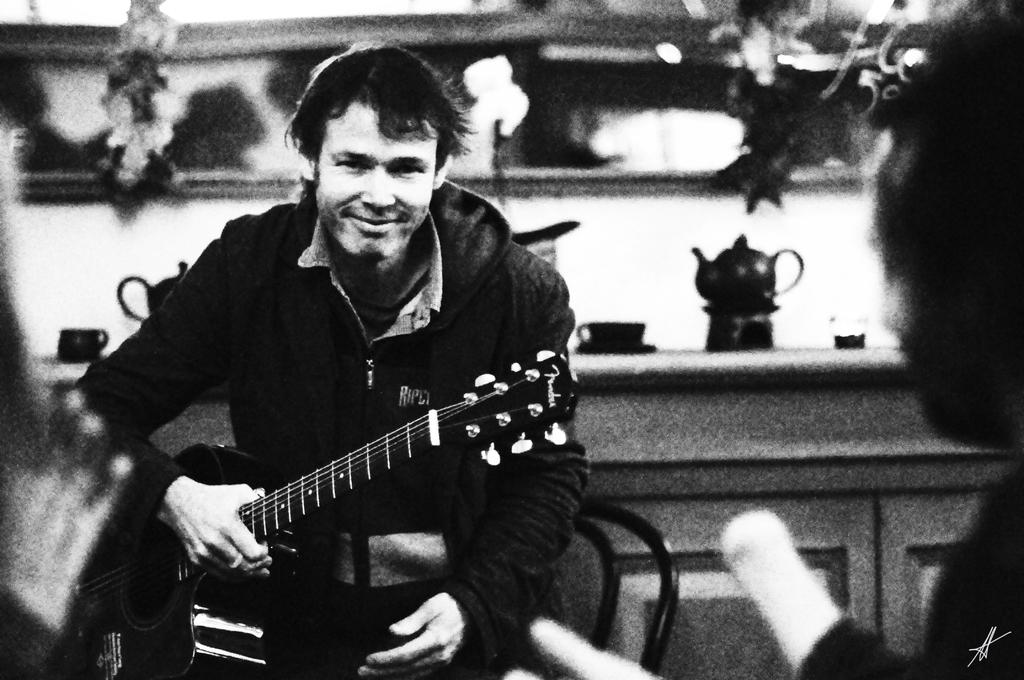What can be seen in the image? There is a person in the image. What is the person wearing? The person is wearing a black jacket. What is the person holding? The person is holding a guitar. What objects can be seen in the background of the image? There is a cup and a tea kettle on top of a table in the background of the image. What book is the person reading in the image? There is no book present in the image; the person is holding a guitar. 